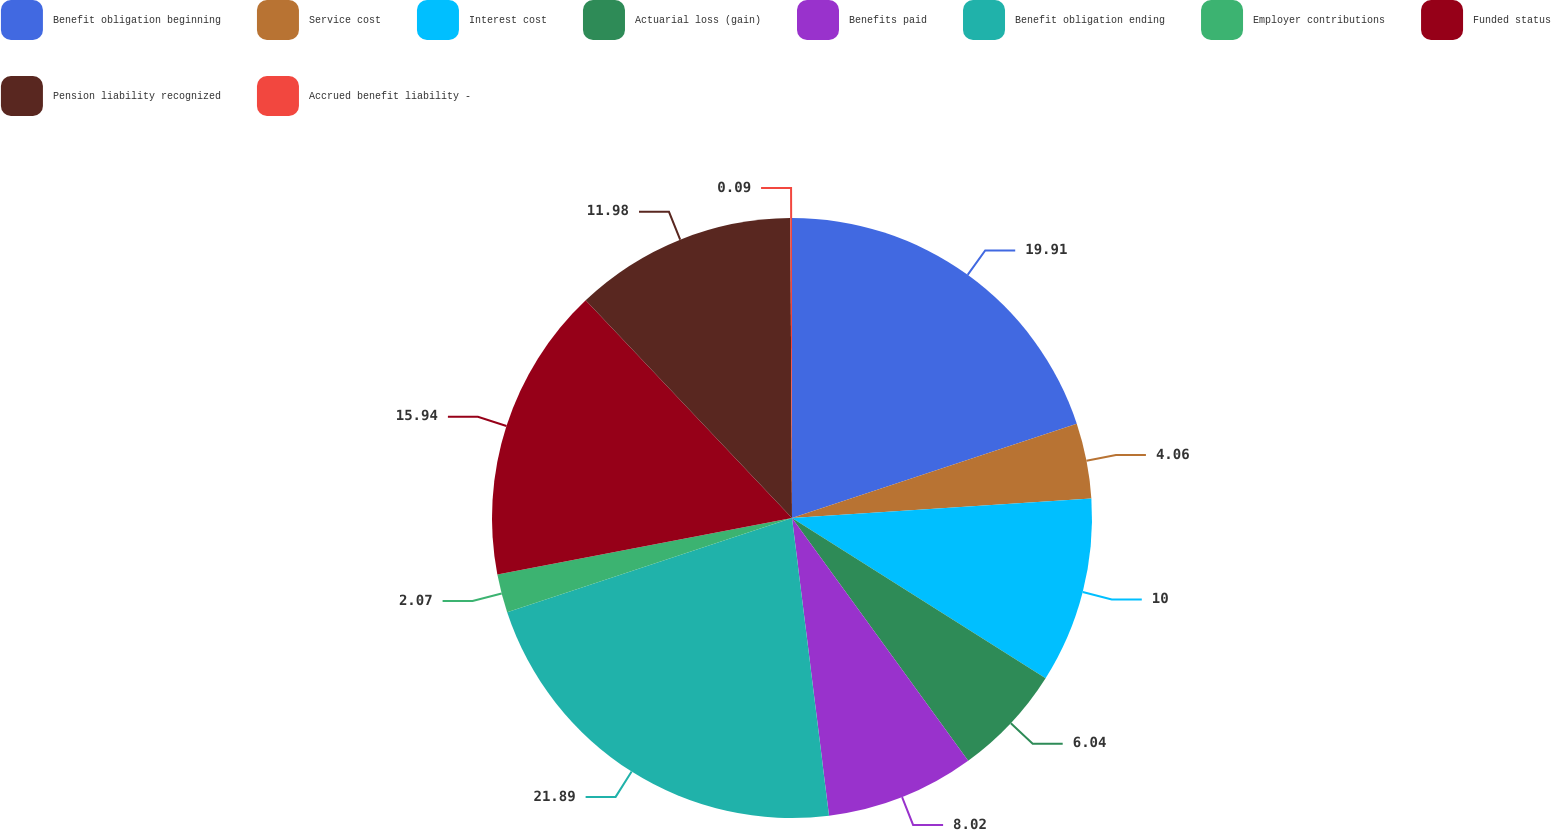<chart> <loc_0><loc_0><loc_500><loc_500><pie_chart><fcel>Benefit obligation beginning<fcel>Service cost<fcel>Interest cost<fcel>Actuarial loss (gain)<fcel>Benefits paid<fcel>Benefit obligation ending<fcel>Employer contributions<fcel>Funded status<fcel>Pension liability recognized<fcel>Accrued benefit liability -<nl><fcel>19.91%<fcel>4.06%<fcel>10.0%<fcel>6.04%<fcel>8.02%<fcel>21.89%<fcel>2.07%<fcel>15.94%<fcel>11.98%<fcel>0.09%<nl></chart> 